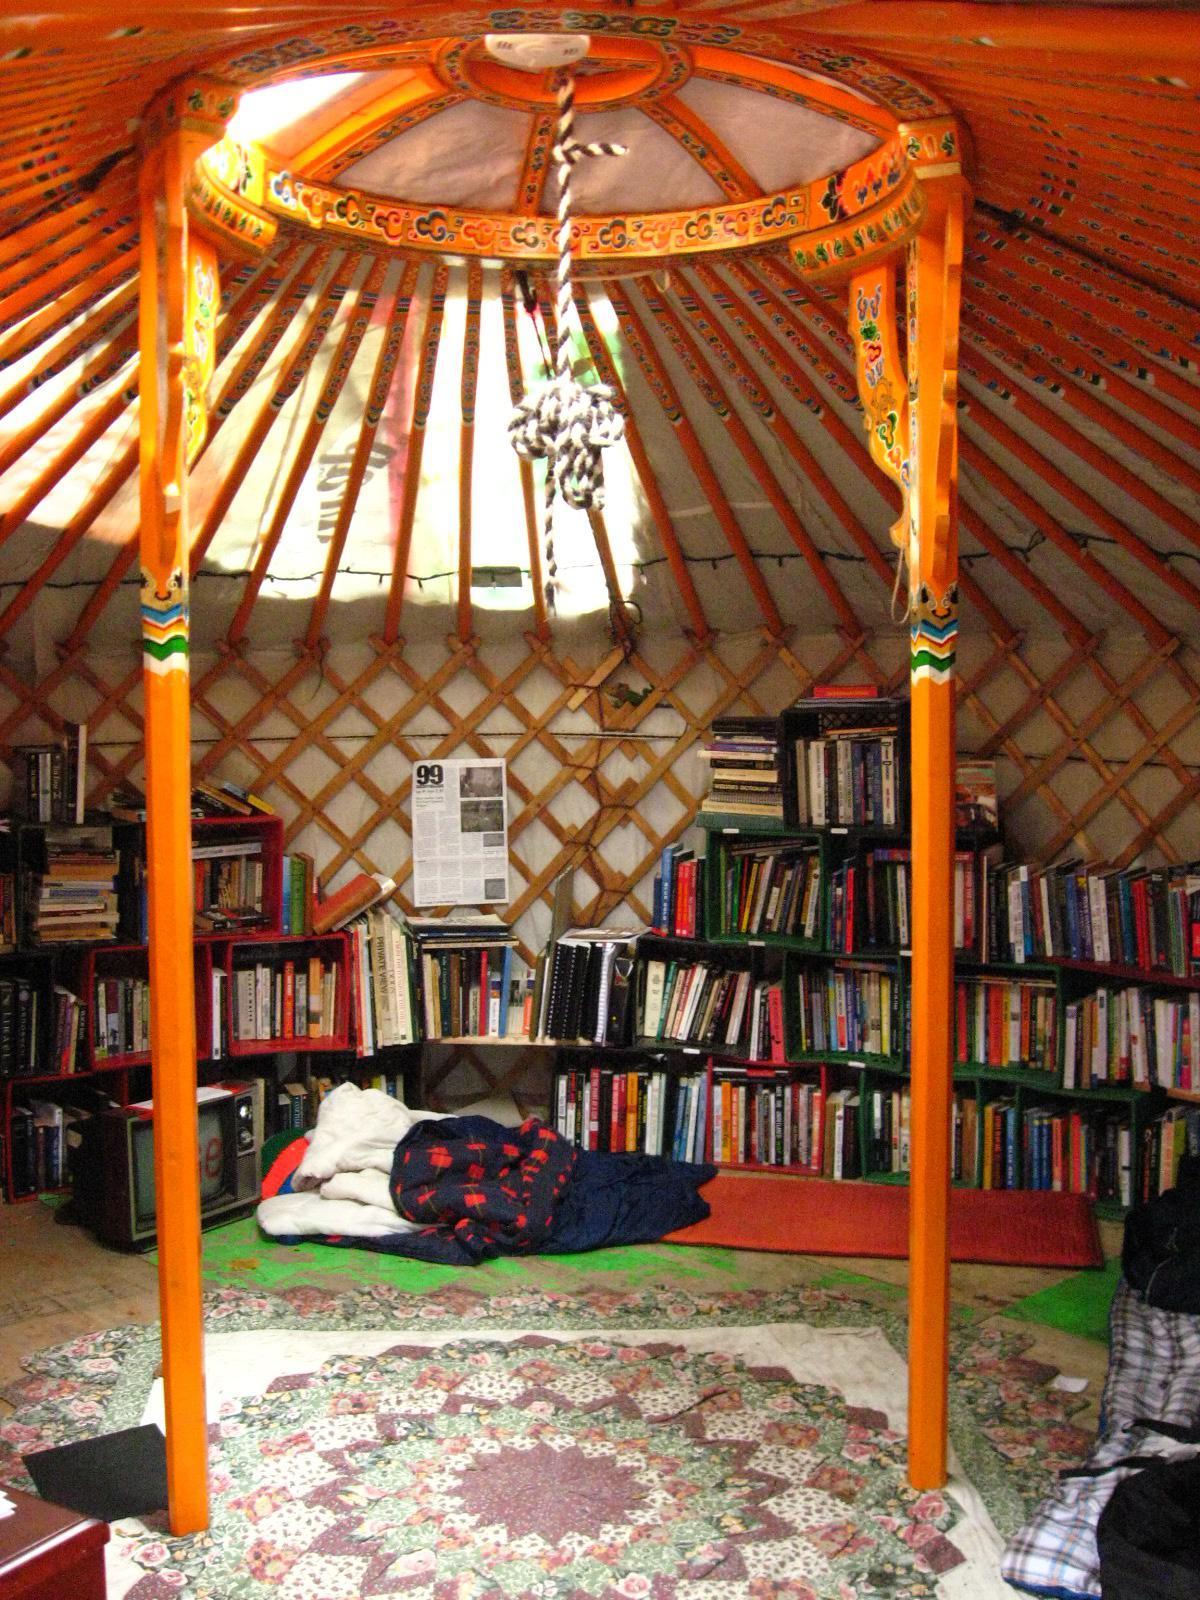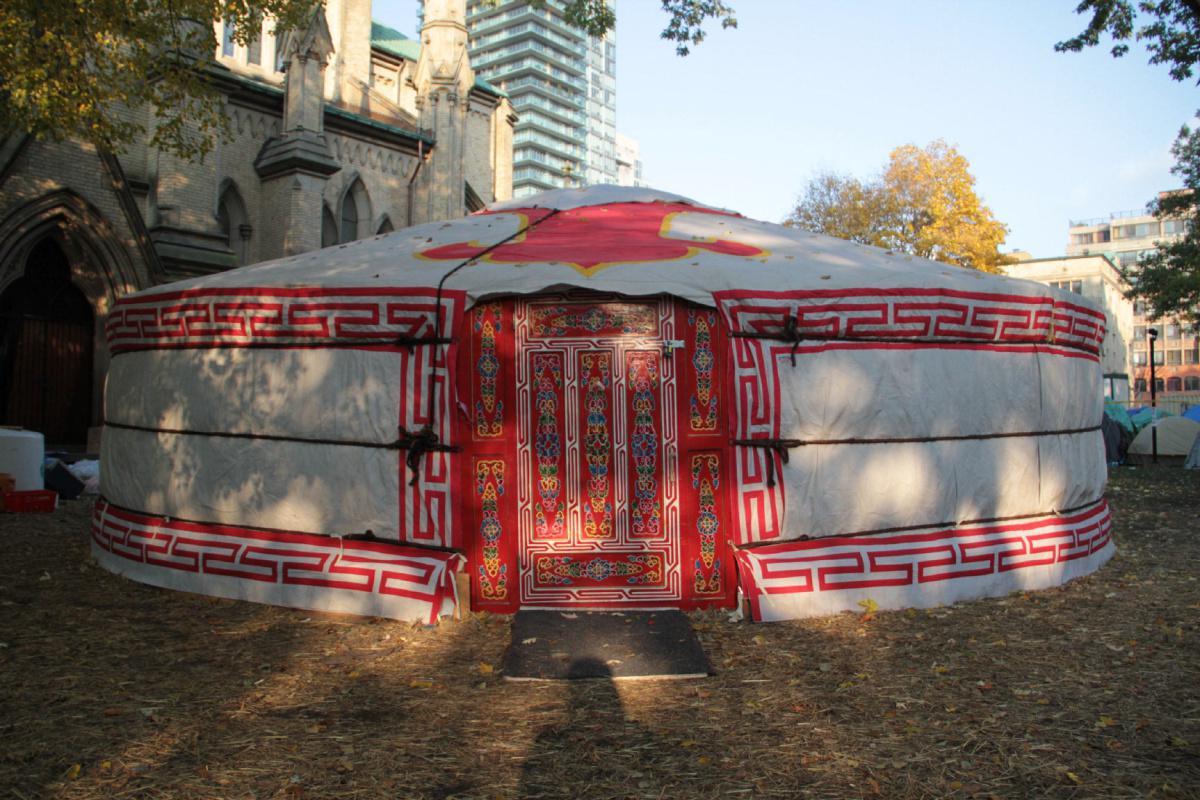The first image is the image on the left, the second image is the image on the right. For the images shown, is this caption "Exterior view of a tent with a red door." true? Answer yes or no. Yes. 